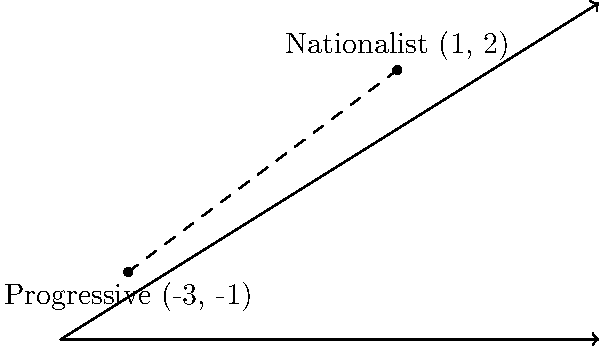On a coordinate plane representing ideological positions, a nationalist influencer's views are represented by the point (1, 2), while your progressive stance is at (-3, -1). Calculate the ideological distance between these two positions using the distance formula. Round your answer to two decimal places. To find the distance between two points on a coordinate plane, we use the distance formula:

$$ d = \sqrt{(x_2 - x_1)^2 + (y_2 - y_1)^2} $$

Where $(x_1, y_1)$ represents the first point and $(x_2, y_2)$ represents the second point.

Given:
- Nationalist point: (1, 2)
- Progressive point: (-3, -1)

Let's plug these into the formula:

$$ d = \sqrt{(-3 - 1)^2 + (-1 - 2)^2} $$

Simplify inside the parentheses:
$$ d = \sqrt{(-4)^2 + (-3)^2} $$

Calculate the squares:
$$ d = \sqrt{16 + 9} $$

Add under the square root:
$$ d = \sqrt{25} $$

Simplify:
$$ d = 5 $$

The exact distance is 5 units. Since the question asks for the answer rounded to two decimal places, our final answer is 5.00.
Answer: 5.00 